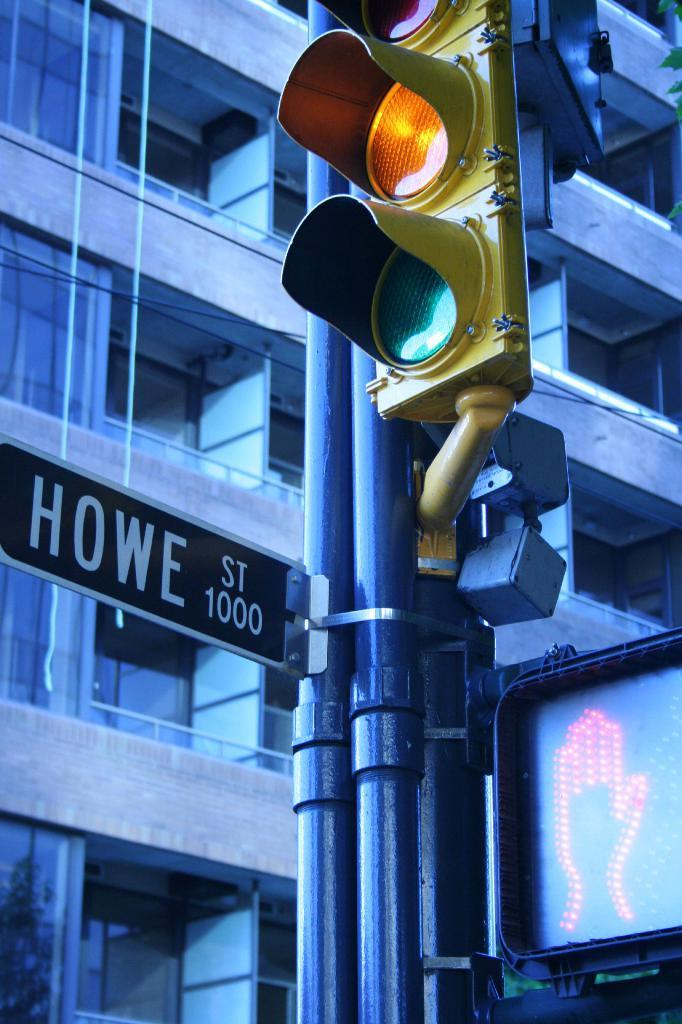<image>
Present a compact description of the photo's key features. A yellow light and a do not walk signal are lit on Howe St. 